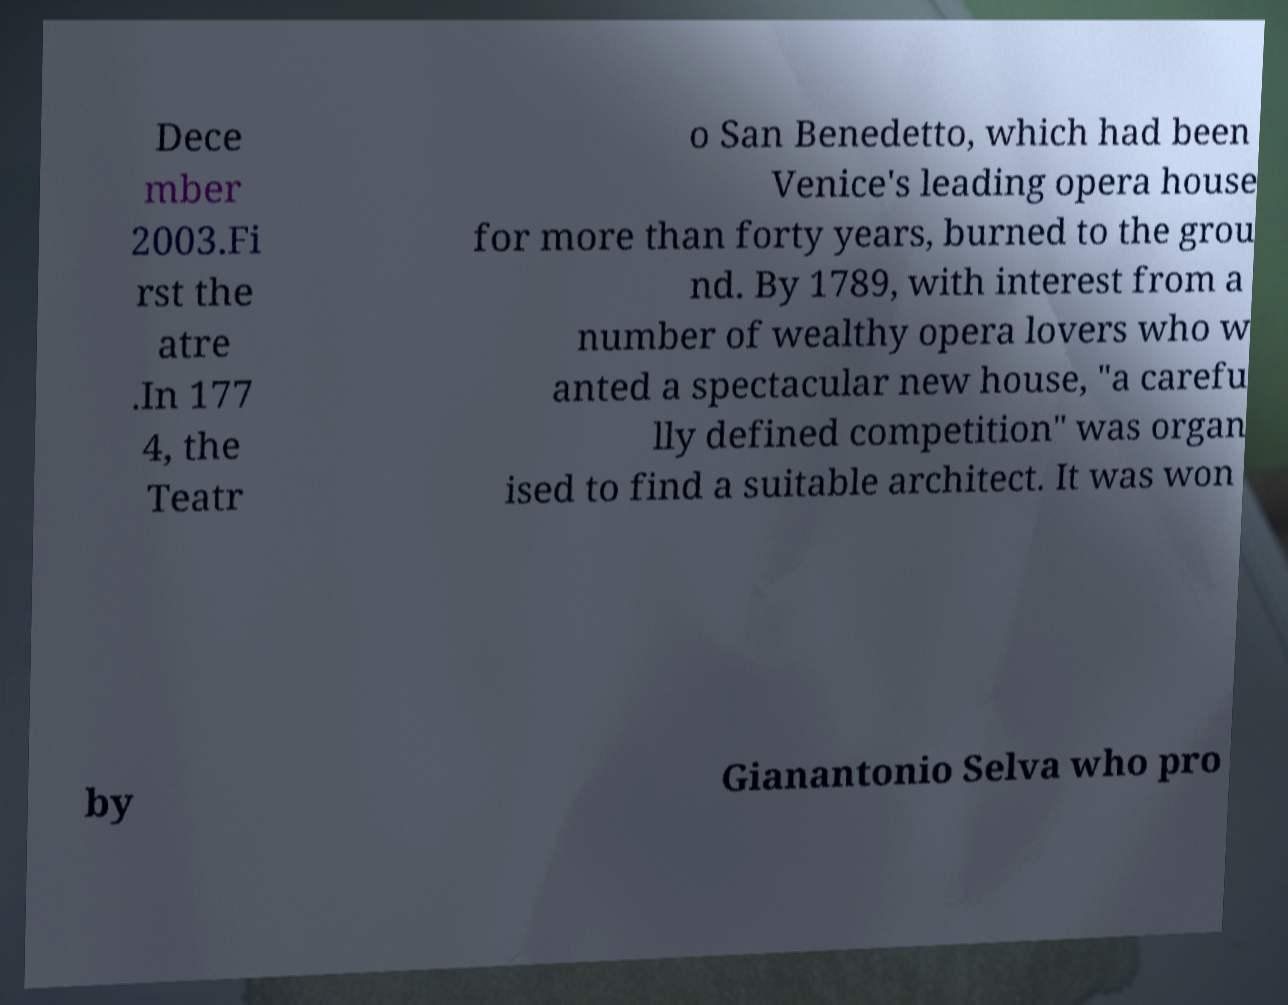Could you extract and type out the text from this image? Dece mber 2003.Fi rst the atre .In 177 4, the Teatr o San Benedetto, which had been Venice's leading opera house for more than forty years, burned to the grou nd. By 1789, with interest from a number of wealthy opera lovers who w anted a spectacular new house, "a carefu lly defined competition" was organ ised to find a suitable architect. It was won by Gianantonio Selva who pro 